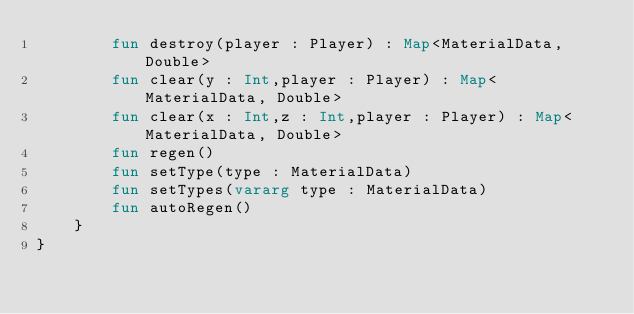<code> <loc_0><loc_0><loc_500><loc_500><_Kotlin_>        fun destroy(player : Player) : Map<MaterialData, Double>
        fun clear(y : Int,player : Player) : Map<MaterialData, Double>
        fun clear(x : Int,z : Int,player : Player) : Map<MaterialData, Double>
        fun regen()
        fun setType(type : MaterialData)
        fun setTypes(vararg type : MaterialData)
        fun autoRegen()
    }
}</code> 